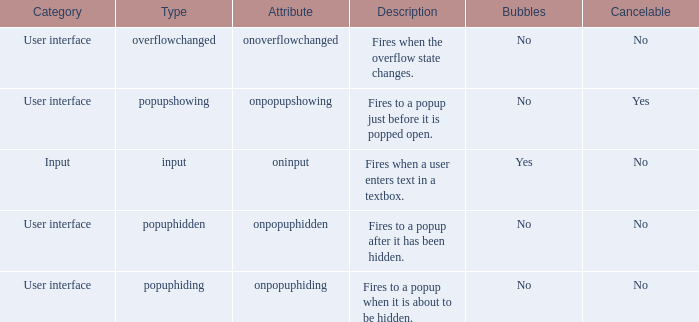What's the type with description being fires when the overflow state changes. Overflowchanged. 